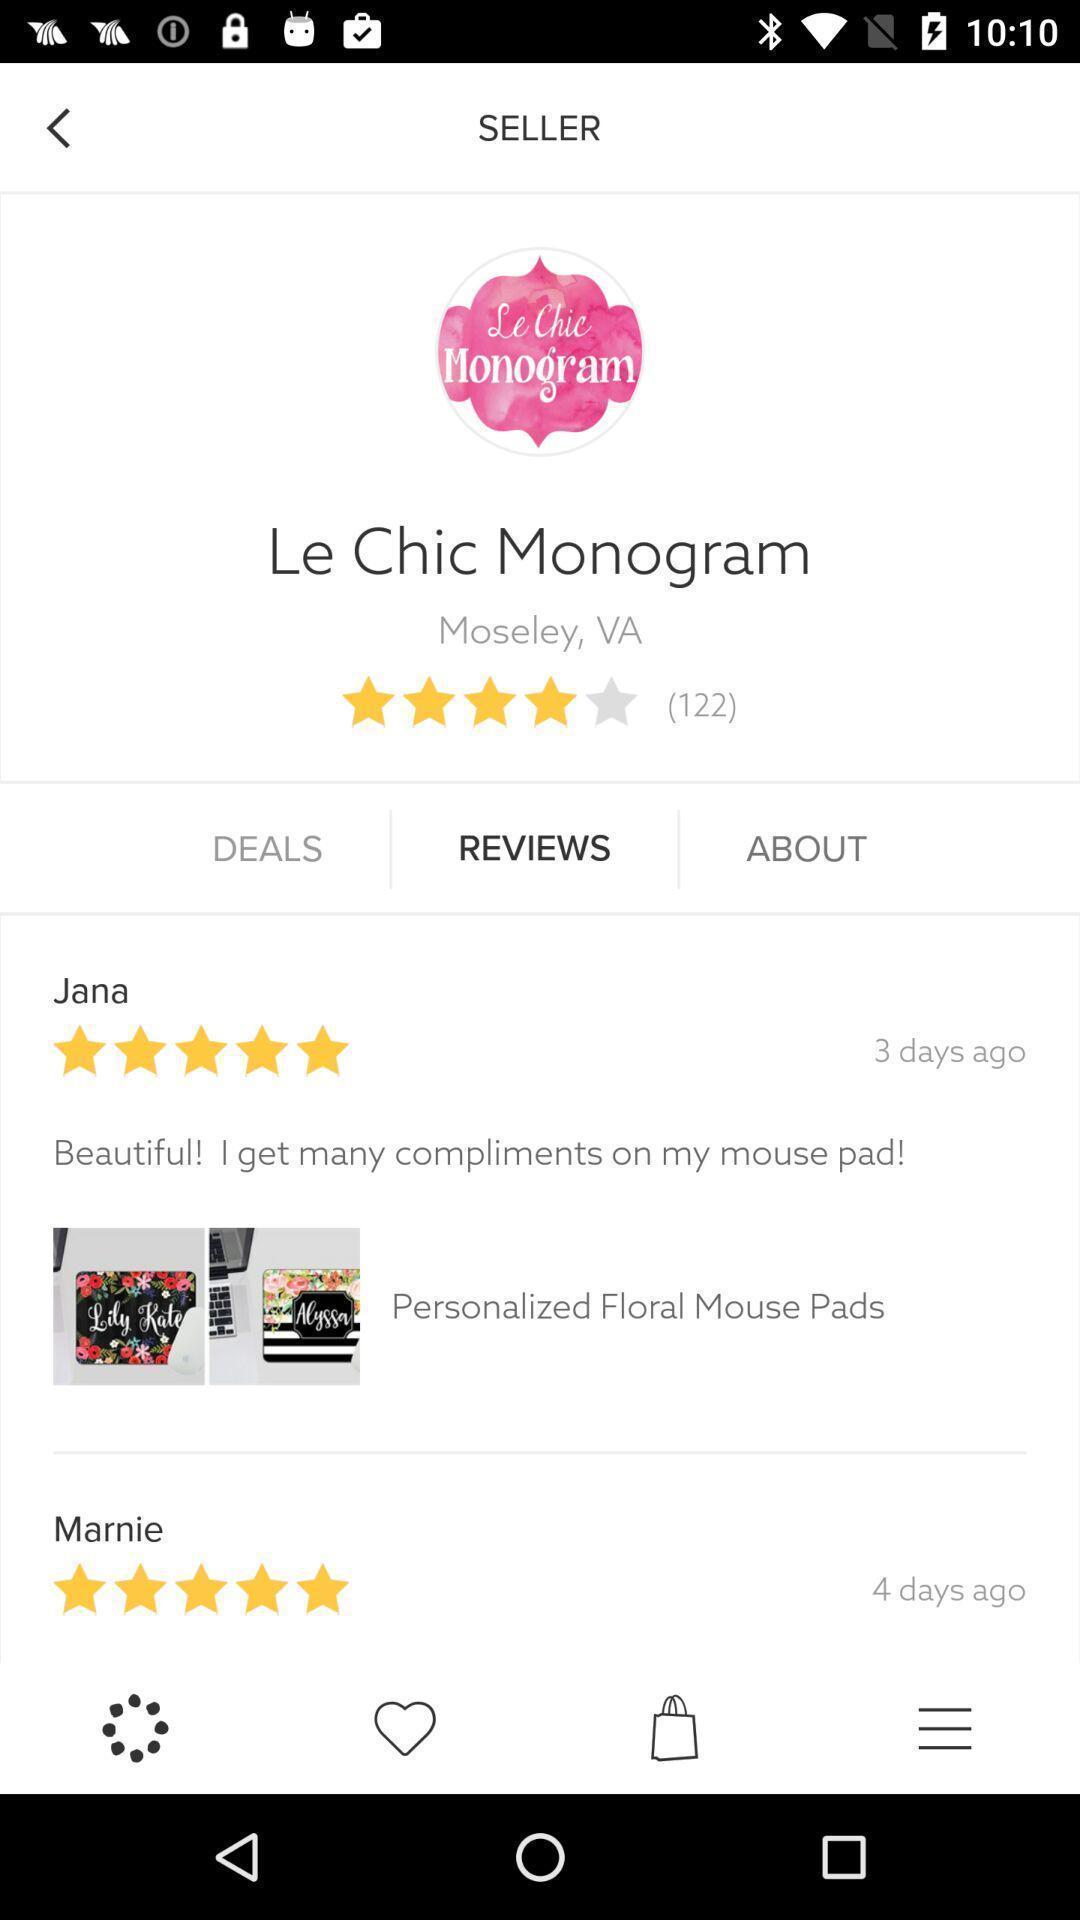Explain what's happening in this screen capture. Screen displaying multiple user reviews in a shopping application. 